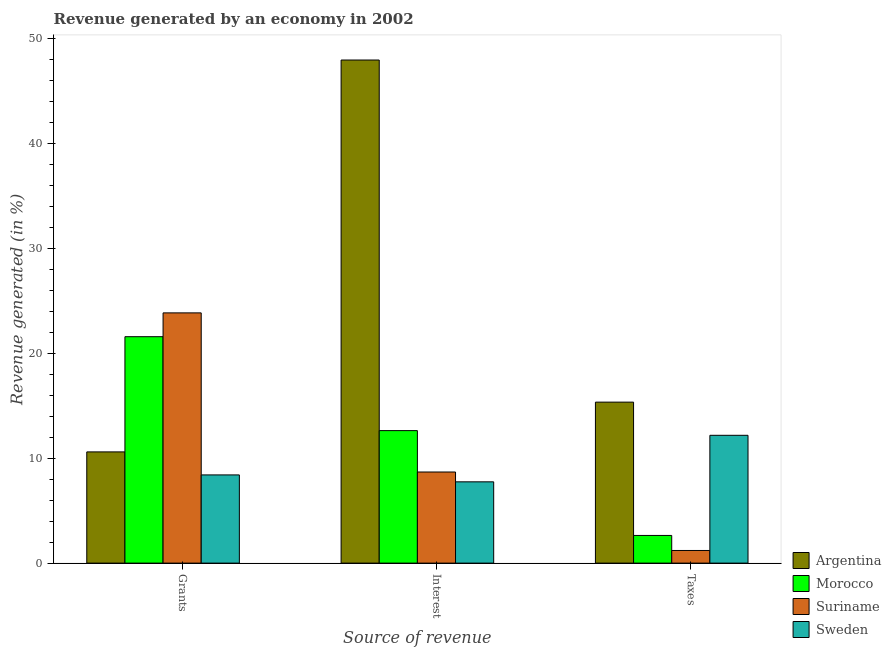How many different coloured bars are there?
Provide a short and direct response. 4. How many groups of bars are there?
Offer a very short reply. 3. Are the number of bars per tick equal to the number of legend labels?
Give a very brief answer. Yes. How many bars are there on the 2nd tick from the right?
Offer a terse response. 4. What is the label of the 1st group of bars from the left?
Keep it short and to the point. Grants. What is the percentage of revenue generated by interest in Suriname?
Give a very brief answer. 8.68. Across all countries, what is the maximum percentage of revenue generated by taxes?
Your answer should be very brief. 15.33. Across all countries, what is the minimum percentage of revenue generated by interest?
Ensure brevity in your answer.  7.74. In which country was the percentage of revenue generated by taxes minimum?
Give a very brief answer. Suriname. What is the total percentage of revenue generated by interest in the graph?
Give a very brief answer. 76.95. What is the difference between the percentage of revenue generated by grants in Suriname and that in Argentina?
Your response must be concise. 13.24. What is the difference between the percentage of revenue generated by interest in Suriname and the percentage of revenue generated by taxes in Argentina?
Provide a succinct answer. -6.65. What is the average percentage of revenue generated by taxes per country?
Give a very brief answer. 7.84. What is the difference between the percentage of revenue generated by interest and percentage of revenue generated by grants in Morocco?
Your answer should be compact. -8.95. What is the ratio of the percentage of revenue generated by interest in Argentina to that in Suriname?
Ensure brevity in your answer.  5.52. What is the difference between the highest and the second highest percentage of revenue generated by taxes?
Your answer should be compact. 3.16. What is the difference between the highest and the lowest percentage of revenue generated by interest?
Provide a succinct answer. 40.17. Is the sum of the percentage of revenue generated by grants in Suriname and Argentina greater than the maximum percentage of revenue generated by interest across all countries?
Your answer should be very brief. No. What does the 3rd bar from the left in Taxes represents?
Your response must be concise. Suriname. What does the 2nd bar from the right in Grants represents?
Your response must be concise. Suriname. How many bars are there?
Keep it short and to the point. 12. Are all the bars in the graph horizontal?
Offer a very short reply. No. What is the difference between two consecutive major ticks on the Y-axis?
Provide a short and direct response. 10. Does the graph contain any zero values?
Ensure brevity in your answer.  No. How many legend labels are there?
Make the answer very short. 4. What is the title of the graph?
Give a very brief answer. Revenue generated by an economy in 2002. Does "Romania" appear as one of the legend labels in the graph?
Your answer should be very brief. No. What is the label or title of the X-axis?
Ensure brevity in your answer.  Source of revenue. What is the label or title of the Y-axis?
Offer a very short reply. Revenue generated (in %). What is the Revenue generated (in %) in Argentina in Grants?
Make the answer very short. 10.59. What is the Revenue generated (in %) in Morocco in Grants?
Provide a short and direct response. 21.56. What is the Revenue generated (in %) of Suriname in Grants?
Your response must be concise. 23.83. What is the Revenue generated (in %) of Sweden in Grants?
Your answer should be very brief. 8.4. What is the Revenue generated (in %) of Argentina in Interest?
Offer a very short reply. 47.91. What is the Revenue generated (in %) of Morocco in Interest?
Provide a short and direct response. 12.62. What is the Revenue generated (in %) of Suriname in Interest?
Provide a succinct answer. 8.68. What is the Revenue generated (in %) of Sweden in Interest?
Your answer should be very brief. 7.74. What is the Revenue generated (in %) of Argentina in Taxes?
Offer a very short reply. 15.33. What is the Revenue generated (in %) of Morocco in Taxes?
Make the answer very short. 2.64. What is the Revenue generated (in %) of Suriname in Taxes?
Give a very brief answer. 1.2. What is the Revenue generated (in %) in Sweden in Taxes?
Make the answer very short. 12.17. Across all Source of revenue, what is the maximum Revenue generated (in %) of Argentina?
Offer a terse response. 47.91. Across all Source of revenue, what is the maximum Revenue generated (in %) in Morocco?
Ensure brevity in your answer.  21.56. Across all Source of revenue, what is the maximum Revenue generated (in %) of Suriname?
Your response must be concise. 23.83. Across all Source of revenue, what is the maximum Revenue generated (in %) of Sweden?
Your response must be concise. 12.17. Across all Source of revenue, what is the minimum Revenue generated (in %) in Argentina?
Your answer should be compact. 10.59. Across all Source of revenue, what is the minimum Revenue generated (in %) in Morocco?
Ensure brevity in your answer.  2.64. Across all Source of revenue, what is the minimum Revenue generated (in %) in Suriname?
Keep it short and to the point. 1.2. Across all Source of revenue, what is the minimum Revenue generated (in %) of Sweden?
Provide a short and direct response. 7.74. What is the total Revenue generated (in %) in Argentina in the graph?
Your response must be concise. 73.83. What is the total Revenue generated (in %) in Morocco in the graph?
Provide a short and direct response. 36.82. What is the total Revenue generated (in %) of Suriname in the graph?
Make the answer very short. 33.71. What is the total Revenue generated (in %) of Sweden in the graph?
Make the answer very short. 28.31. What is the difference between the Revenue generated (in %) of Argentina in Grants and that in Interest?
Keep it short and to the point. -37.32. What is the difference between the Revenue generated (in %) in Morocco in Grants and that in Interest?
Offer a very short reply. 8.95. What is the difference between the Revenue generated (in %) of Suriname in Grants and that in Interest?
Your response must be concise. 15.15. What is the difference between the Revenue generated (in %) of Sweden in Grants and that in Interest?
Your answer should be compact. 0.66. What is the difference between the Revenue generated (in %) of Argentina in Grants and that in Taxes?
Offer a terse response. -4.74. What is the difference between the Revenue generated (in %) in Morocco in Grants and that in Taxes?
Keep it short and to the point. 18.93. What is the difference between the Revenue generated (in %) in Suriname in Grants and that in Taxes?
Provide a succinct answer. 22.63. What is the difference between the Revenue generated (in %) of Sweden in Grants and that in Taxes?
Give a very brief answer. -3.77. What is the difference between the Revenue generated (in %) of Argentina in Interest and that in Taxes?
Provide a succinct answer. 32.58. What is the difference between the Revenue generated (in %) in Morocco in Interest and that in Taxes?
Make the answer very short. 9.98. What is the difference between the Revenue generated (in %) of Suriname in Interest and that in Taxes?
Your response must be concise. 7.47. What is the difference between the Revenue generated (in %) in Sweden in Interest and that in Taxes?
Your answer should be compact. -4.43. What is the difference between the Revenue generated (in %) in Argentina in Grants and the Revenue generated (in %) in Morocco in Interest?
Your response must be concise. -2.03. What is the difference between the Revenue generated (in %) of Argentina in Grants and the Revenue generated (in %) of Suriname in Interest?
Make the answer very short. 1.91. What is the difference between the Revenue generated (in %) in Argentina in Grants and the Revenue generated (in %) in Sweden in Interest?
Ensure brevity in your answer.  2.85. What is the difference between the Revenue generated (in %) of Morocco in Grants and the Revenue generated (in %) of Suriname in Interest?
Offer a very short reply. 12.89. What is the difference between the Revenue generated (in %) of Morocco in Grants and the Revenue generated (in %) of Sweden in Interest?
Your response must be concise. 13.82. What is the difference between the Revenue generated (in %) in Suriname in Grants and the Revenue generated (in %) in Sweden in Interest?
Keep it short and to the point. 16.09. What is the difference between the Revenue generated (in %) in Argentina in Grants and the Revenue generated (in %) in Morocco in Taxes?
Provide a succinct answer. 7.95. What is the difference between the Revenue generated (in %) of Argentina in Grants and the Revenue generated (in %) of Suriname in Taxes?
Give a very brief answer. 9.39. What is the difference between the Revenue generated (in %) of Argentina in Grants and the Revenue generated (in %) of Sweden in Taxes?
Offer a very short reply. -1.58. What is the difference between the Revenue generated (in %) in Morocco in Grants and the Revenue generated (in %) in Suriname in Taxes?
Your answer should be very brief. 20.36. What is the difference between the Revenue generated (in %) of Morocco in Grants and the Revenue generated (in %) of Sweden in Taxes?
Offer a very short reply. 9.39. What is the difference between the Revenue generated (in %) in Suriname in Grants and the Revenue generated (in %) in Sweden in Taxes?
Ensure brevity in your answer.  11.66. What is the difference between the Revenue generated (in %) in Argentina in Interest and the Revenue generated (in %) in Morocco in Taxes?
Ensure brevity in your answer.  45.27. What is the difference between the Revenue generated (in %) of Argentina in Interest and the Revenue generated (in %) of Suriname in Taxes?
Make the answer very short. 46.71. What is the difference between the Revenue generated (in %) of Argentina in Interest and the Revenue generated (in %) of Sweden in Taxes?
Provide a succinct answer. 35.74. What is the difference between the Revenue generated (in %) in Morocco in Interest and the Revenue generated (in %) in Suriname in Taxes?
Give a very brief answer. 11.41. What is the difference between the Revenue generated (in %) of Morocco in Interest and the Revenue generated (in %) of Sweden in Taxes?
Provide a succinct answer. 0.45. What is the difference between the Revenue generated (in %) in Suriname in Interest and the Revenue generated (in %) in Sweden in Taxes?
Keep it short and to the point. -3.49. What is the average Revenue generated (in %) in Argentina per Source of revenue?
Keep it short and to the point. 24.61. What is the average Revenue generated (in %) of Morocco per Source of revenue?
Ensure brevity in your answer.  12.27. What is the average Revenue generated (in %) in Suriname per Source of revenue?
Make the answer very short. 11.24. What is the average Revenue generated (in %) in Sweden per Source of revenue?
Ensure brevity in your answer.  9.44. What is the difference between the Revenue generated (in %) in Argentina and Revenue generated (in %) in Morocco in Grants?
Your answer should be compact. -10.97. What is the difference between the Revenue generated (in %) in Argentina and Revenue generated (in %) in Suriname in Grants?
Give a very brief answer. -13.24. What is the difference between the Revenue generated (in %) in Argentina and Revenue generated (in %) in Sweden in Grants?
Provide a succinct answer. 2.19. What is the difference between the Revenue generated (in %) of Morocco and Revenue generated (in %) of Suriname in Grants?
Give a very brief answer. -2.27. What is the difference between the Revenue generated (in %) of Morocco and Revenue generated (in %) of Sweden in Grants?
Offer a terse response. 13.16. What is the difference between the Revenue generated (in %) of Suriname and Revenue generated (in %) of Sweden in Grants?
Provide a succinct answer. 15.43. What is the difference between the Revenue generated (in %) in Argentina and Revenue generated (in %) in Morocco in Interest?
Your answer should be compact. 35.29. What is the difference between the Revenue generated (in %) of Argentina and Revenue generated (in %) of Suriname in Interest?
Make the answer very short. 39.23. What is the difference between the Revenue generated (in %) of Argentina and Revenue generated (in %) of Sweden in Interest?
Offer a very short reply. 40.17. What is the difference between the Revenue generated (in %) in Morocco and Revenue generated (in %) in Suriname in Interest?
Your response must be concise. 3.94. What is the difference between the Revenue generated (in %) of Morocco and Revenue generated (in %) of Sweden in Interest?
Provide a succinct answer. 4.88. What is the difference between the Revenue generated (in %) in Suriname and Revenue generated (in %) in Sweden in Interest?
Offer a very short reply. 0.94. What is the difference between the Revenue generated (in %) in Argentina and Revenue generated (in %) in Morocco in Taxes?
Your response must be concise. 12.7. What is the difference between the Revenue generated (in %) of Argentina and Revenue generated (in %) of Suriname in Taxes?
Keep it short and to the point. 14.13. What is the difference between the Revenue generated (in %) of Argentina and Revenue generated (in %) of Sweden in Taxes?
Offer a terse response. 3.16. What is the difference between the Revenue generated (in %) in Morocco and Revenue generated (in %) in Suriname in Taxes?
Offer a terse response. 1.43. What is the difference between the Revenue generated (in %) in Morocco and Revenue generated (in %) in Sweden in Taxes?
Ensure brevity in your answer.  -9.54. What is the difference between the Revenue generated (in %) of Suriname and Revenue generated (in %) of Sweden in Taxes?
Your response must be concise. -10.97. What is the ratio of the Revenue generated (in %) of Argentina in Grants to that in Interest?
Your answer should be compact. 0.22. What is the ratio of the Revenue generated (in %) in Morocco in Grants to that in Interest?
Ensure brevity in your answer.  1.71. What is the ratio of the Revenue generated (in %) in Suriname in Grants to that in Interest?
Your answer should be very brief. 2.75. What is the ratio of the Revenue generated (in %) of Sweden in Grants to that in Interest?
Your response must be concise. 1.08. What is the ratio of the Revenue generated (in %) in Argentina in Grants to that in Taxes?
Offer a terse response. 0.69. What is the ratio of the Revenue generated (in %) of Morocco in Grants to that in Taxes?
Give a very brief answer. 8.18. What is the ratio of the Revenue generated (in %) of Suriname in Grants to that in Taxes?
Make the answer very short. 19.8. What is the ratio of the Revenue generated (in %) of Sweden in Grants to that in Taxes?
Your answer should be very brief. 0.69. What is the ratio of the Revenue generated (in %) of Argentina in Interest to that in Taxes?
Give a very brief answer. 3.12. What is the ratio of the Revenue generated (in %) in Morocco in Interest to that in Taxes?
Provide a short and direct response. 4.79. What is the ratio of the Revenue generated (in %) of Suriname in Interest to that in Taxes?
Give a very brief answer. 7.21. What is the ratio of the Revenue generated (in %) in Sweden in Interest to that in Taxes?
Provide a short and direct response. 0.64. What is the difference between the highest and the second highest Revenue generated (in %) in Argentina?
Provide a short and direct response. 32.58. What is the difference between the highest and the second highest Revenue generated (in %) in Morocco?
Keep it short and to the point. 8.95. What is the difference between the highest and the second highest Revenue generated (in %) of Suriname?
Ensure brevity in your answer.  15.15. What is the difference between the highest and the second highest Revenue generated (in %) in Sweden?
Provide a short and direct response. 3.77. What is the difference between the highest and the lowest Revenue generated (in %) in Argentina?
Your answer should be very brief. 37.32. What is the difference between the highest and the lowest Revenue generated (in %) in Morocco?
Give a very brief answer. 18.93. What is the difference between the highest and the lowest Revenue generated (in %) in Suriname?
Offer a terse response. 22.63. What is the difference between the highest and the lowest Revenue generated (in %) in Sweden?
Offer a very short reply. 4.43. 